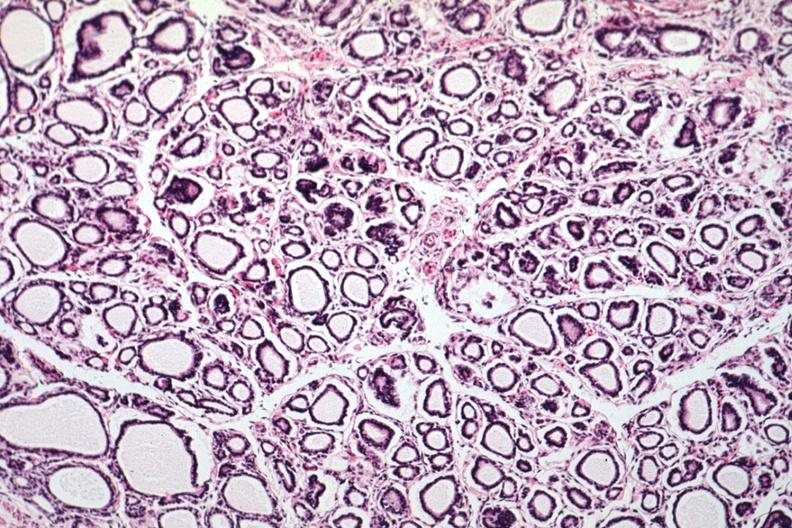s normal immature infant present?
Answer the question using a single word or phrase. Yes 